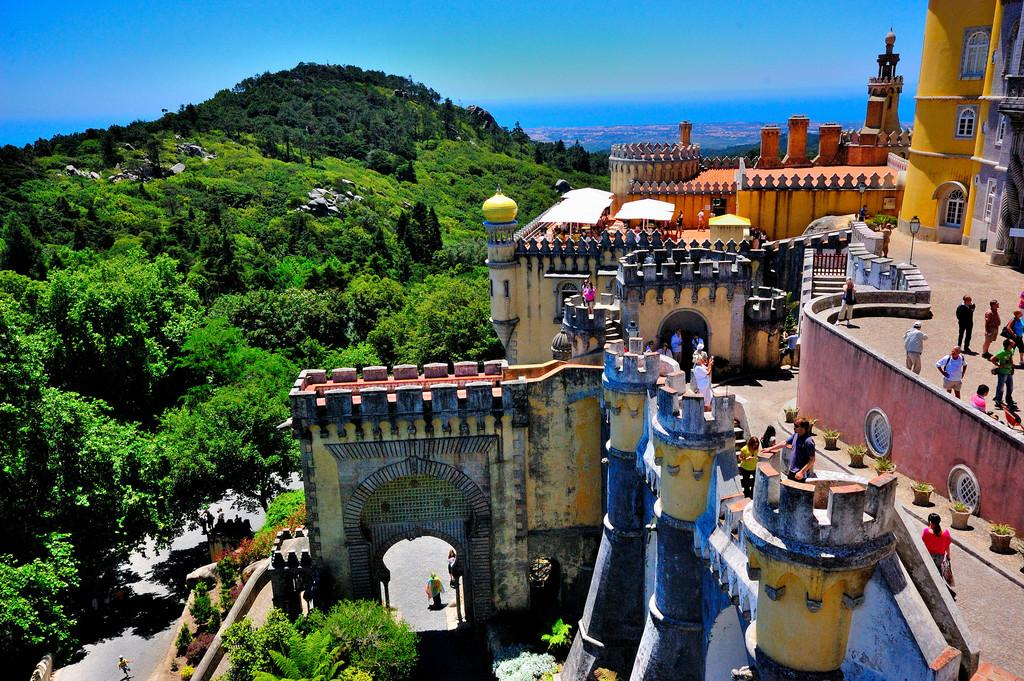What is located in the foreground of the image? There is a place in the foreground of the image. What type of vegetation can be seen on the right side of the image? There is greenery on the right side of the image. What else is present on the right side of the image besides the greenery? There is a road on the right side of the image. What is visible at the top of the image? The sky is visible at the top of the image. What type of meat is being cooked on the hand in the image? There is no hand or meat present in the image. 